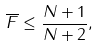Convert formula to latex. <formula><loc_0><loc_0><loc_500><loc_500>\overline { F } \leq \frac { N + 1 } { N + 2 } ,</formula> 